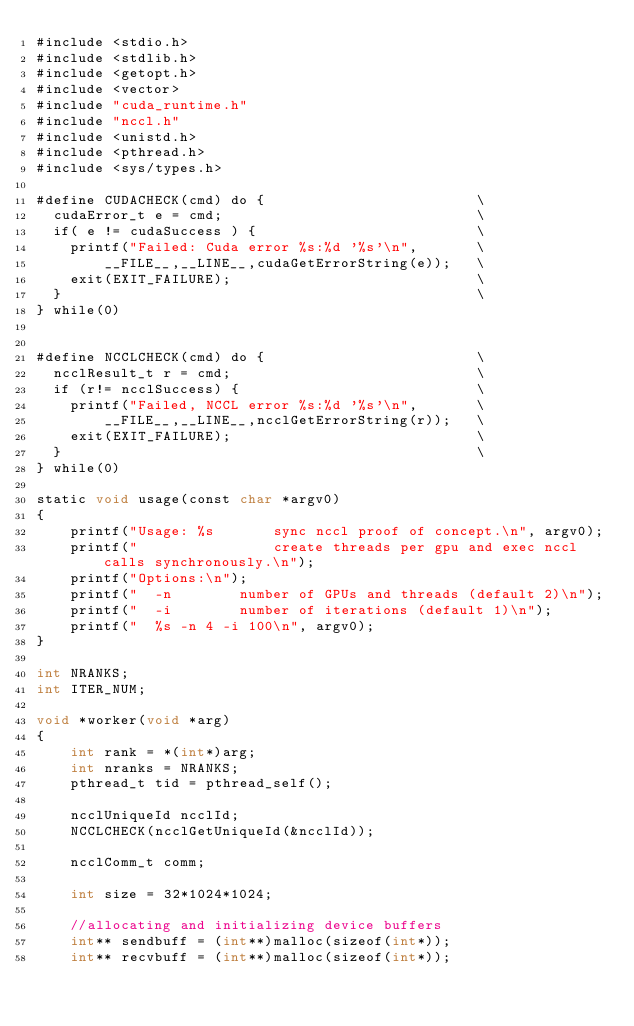Convert code to text. <code><loc_0><loc_0><loc_500><loc_500><_Cuda_>#include <stdio.h>
#include <stdlib.h>
#include <getopt.h>
#include <vector>
#include "cuda_runtime.h"
#include "nccl.h"
#include <unistd.h>
#include <pthread.h>
#include <sys/types.h>

#define CUDACHECK(cmd) do {                         \
  cudaError_t e = cmd;                              \
  if( e != cudaSuccess ) {                          \
    printf("Failed: Cuda error %s:%d '%s'\n",       \
        __FILE__,__LINE__,cudaGetErrorString(e));   \
    exit(EXIT_FAILURE);                             \
  }                                                 \
} while(0)


#define NCCLCHECK(cmd) do {                         \
  ncclResult_t r = cmd;                             \
  if (r!= ncclSuccess) {                            \
    printf("Failed, NCCL error %s:%d '%s'\n",       \
        __FILE__,__LINE__,ncclGetErrorString(r));   \
    exit(EXIT_FAILURE);                             \
  }                                                 \
} while(0)

static void usage(const char *argv0)
{
	printf("Usage: %s       sync nccl proof of concept.\n", argv0);
	printf("                create threads per gpu and exec nccl calls synchronously.\n");
	printf("Options:\n");
    printf("  -n        number of GPUs and threads (default 2)\n");
	printf("  -i        number of iterations (default 1)\n");
	printf("  %s -n 4 -i 100\n", argv0);
}

int NRANKS;
int ITER_NUM;

void *worker(void *arg)
{
    int rank = *(int*)arg;
    int nranks = NRANKS;
    pthread_t tid = pthread_self();

    ncclUniqueId ncclId;
    NCCLCHECK(ncclGetUniqueId(&ncclId));

    ncclComm_t comm;

    int size = 32*1024*1024;

    //allocating and initializing device buffers
    int** sendbuff = (int**)malloc(sizeof(int*));
    int** recvbuff = (int**)malloc(sizeof(int*));</code> 